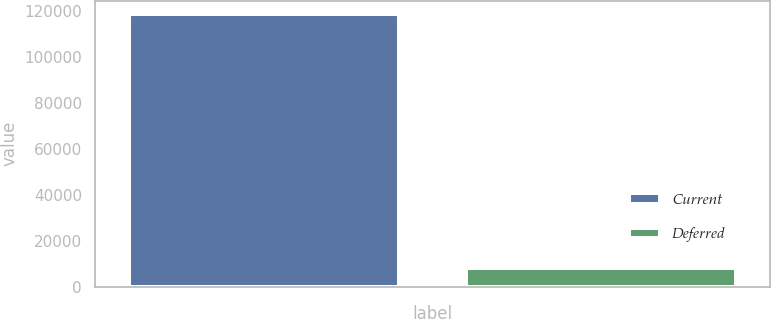Convert chart. <chart><loc_0><loc_0><loc_500><loc_500><bar_chart><fcel>Current<fcel>Deferred<nl><fcel>118741<fcel>8023<nl></chart> 